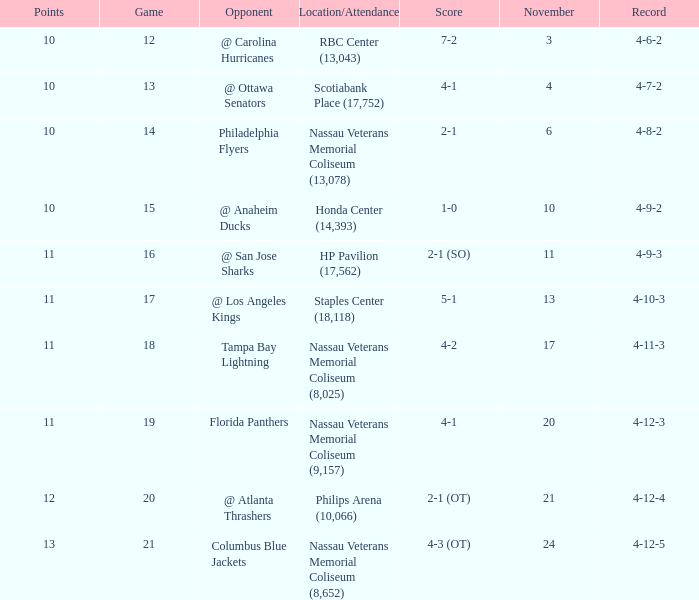What is the least amount of points? 10.0. 